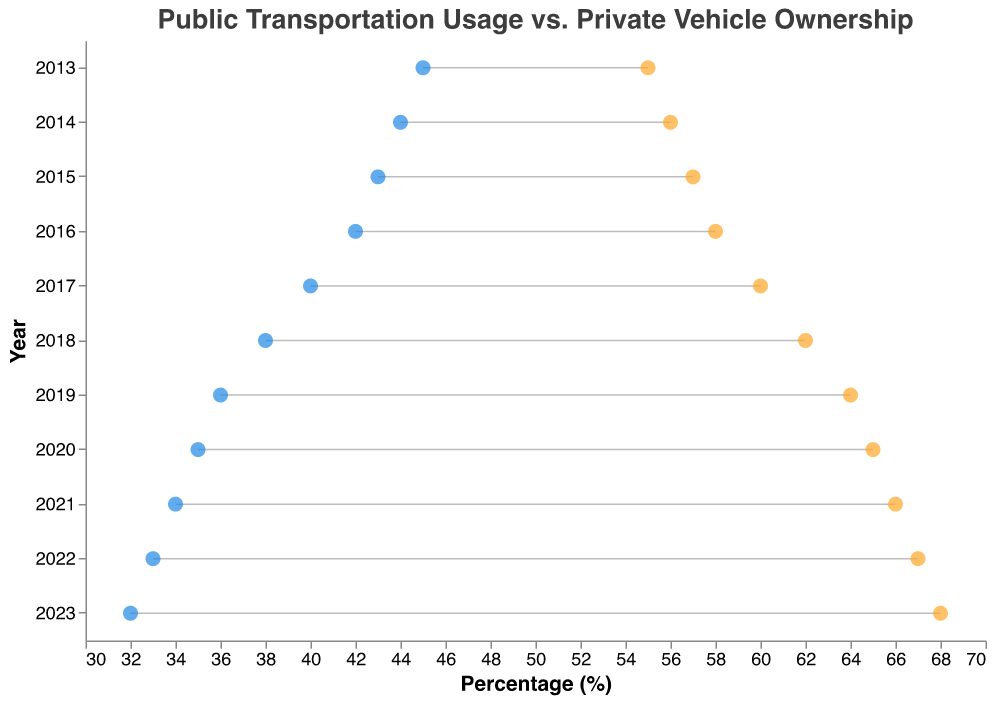What is the title of the plot? The title of the plot is clearly displayed at the top. It reads "Public Transportation Usage vs. Private Vehicle Ownership".
Answer: Public Transportation Usage vs. Private Vehicle Ownership In which year did public transportation usage first drop below 40%? By tracking the percentages through the years, public transportation usage first dropped below 40% in the year 2017.
Answer: 2017 How many years are covered by the data in the plot? The plot shows data points starting from the year 2013 and ending in 2023. Counting these years inclusively gives 11 years.
Answer: 11 Which year shows the largest difference between public transportation usage and private vehicle ownership? To find the year with the largest difference, we compare the differences between the two values for each year. The largest difference is seen in 2023 with a difference of 36% (68% - 32%).
Answer: 2023 How did public transportation usage percentage change from 2013 to 2023? Public transportation usage percentage is shown alongside each year, starting at 45% in 2013 and ending at 32% in 2023. The change is calculated as the initial value minus the final value, which is 45% - 32% = 13%.
Answer: Decreased by 13% Has the percentage of private vehicle ownership increased consistently over the decade? By looking at the private vehicle ownership percentages for each year, it is evident that it has increased steadily each year from 2013 (55%) to 2023 (68%).
Answer: Yes What is the average public transportation usage percentage over the decade? Sum the public transportation usage percentages for all years and divide by the number of years. The sum is 45 + 44 + 43 + 42 + 40 + 38 + 36 + 35 + 34 + 33 + 32 = 422. The average is 422 / 11 = 38.36%.
Answer: 38.36% Which year had the smallest percentage of public transportation usage? By examining the data points for public transportation usage, the smallest percentage is in the year 2023 with 32%.
Answer: 2023 How much did private vehicle ownership increase from 2017 to 2020? Private vehicle ownership in 2017 is 60% and in 2020 it is 65%. The increase is calculated as 65% - 60% = 5%.
Answer: 5% What can you infer from the trends shown in the plot regarding public transportation usage and private vehicle ownership? The plot shows a steady decline in public transportation usage and a corresponding increase in private vehicle ownership over the decade, indicating a shift from public to private transportation preferences.
Answer: Shift from public to private transportation preferences 